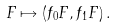Convert formula to latex. <formula><loc_0><loc_0><loc_500><loc_500>F \mapsto ( f _ { 0 } F , f _ { 1 } F ) \, .</formula> 